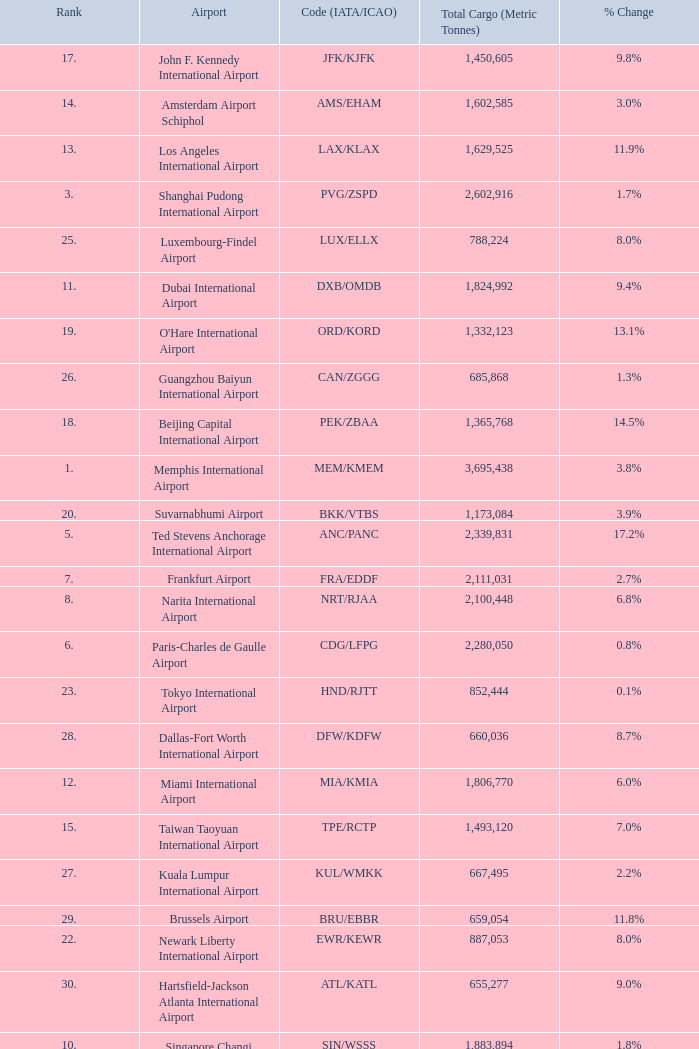What is the code for rank 10? SIN/WSSS. 